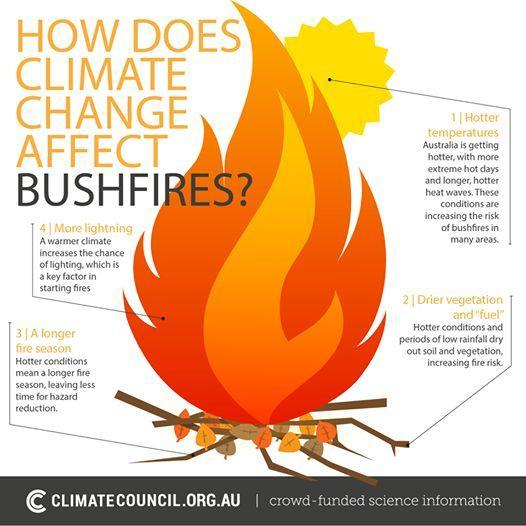What results in less time for hazard reduction?
Answer the question with a short phrase. a longer fire season What is the reason for increasing risk of bushfires in many areas of Australia? Hotter temperatures 